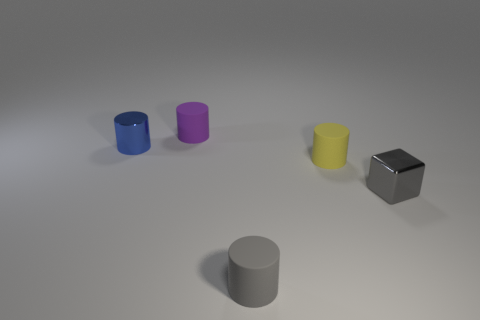Add 1 small shiny cylinders. How many objects exist? 6 Subtract all cubes. How many objects are left? 4 Subtract 0 green cubes. How many objects are left? 5 Subtract all gray metal cubes. Subtract all small yellow objects. How many objects are left? 3 Add 1 small gray cylinders. How many small gray cylinders are left? 2 Add 3 gray rubber objects. How many gray rubber objects exist? 4 